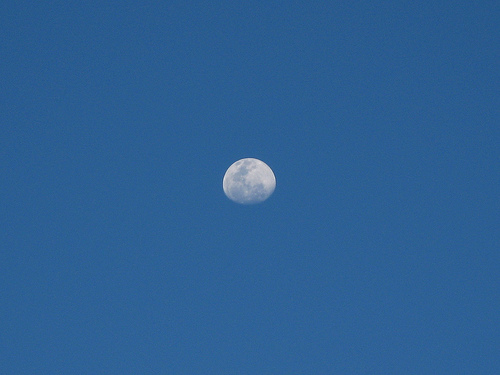<image>
Can you confirm if the moon is next to the sky? No. The moon is not positioned next to the sky. They are located in different areas of the scene. 